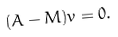<formula> <loc_0><loc_0><loc_500><loc_500>( A - M ) v = 0 .</formula> 